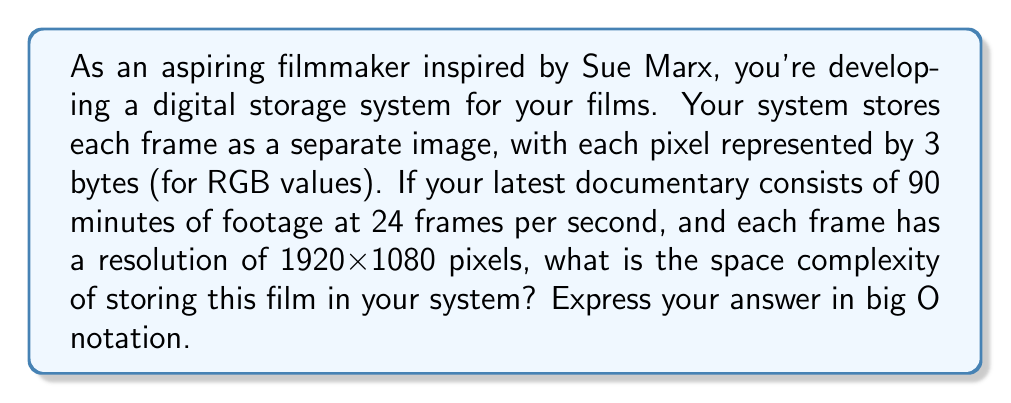Give your solution to this math problem. Let's break this down step by step:

1. Calculate the total number of frames:
   - 90 minutes = 90 * 60 = 5400 seconds
   - Frames per second = 24
   - Total frames = 5400 * 24 = 129,600 frames

2. Calculate the number of pixels per frame:
   - Resolution = 1920 x 1080
   - Pixels per frame = 1920 * 1080 = 2,073,600 pixels

3. Calculate the storage needed for each frame:
   - Each pixel uses 3 bytes
   - Storage per frame = 2,073,600 * 3 = 6,220,800 bytes

4. Calculate the total storage needed:
   - Total storage = 129,600 frames * 6,220,800 bytes/frame
   - Total storage = 806,215,680,000 bytes

5. Express in big O notation:
   The space complexity is directly proportional to the number of frames (n).
   Each frame requires a constant amount of storage (1920 * 1080 * 3 bytes).
   Therefore, the space complexity is $O(n)$, where n is the number of frames.

Note: While the actual storage size is large, in computational complexity, we're concerned with how the space requirements grow with respect to the input size (number of frames), not the constant factors.
Answer: $O(n)$, where n is the number of frames in the film. 